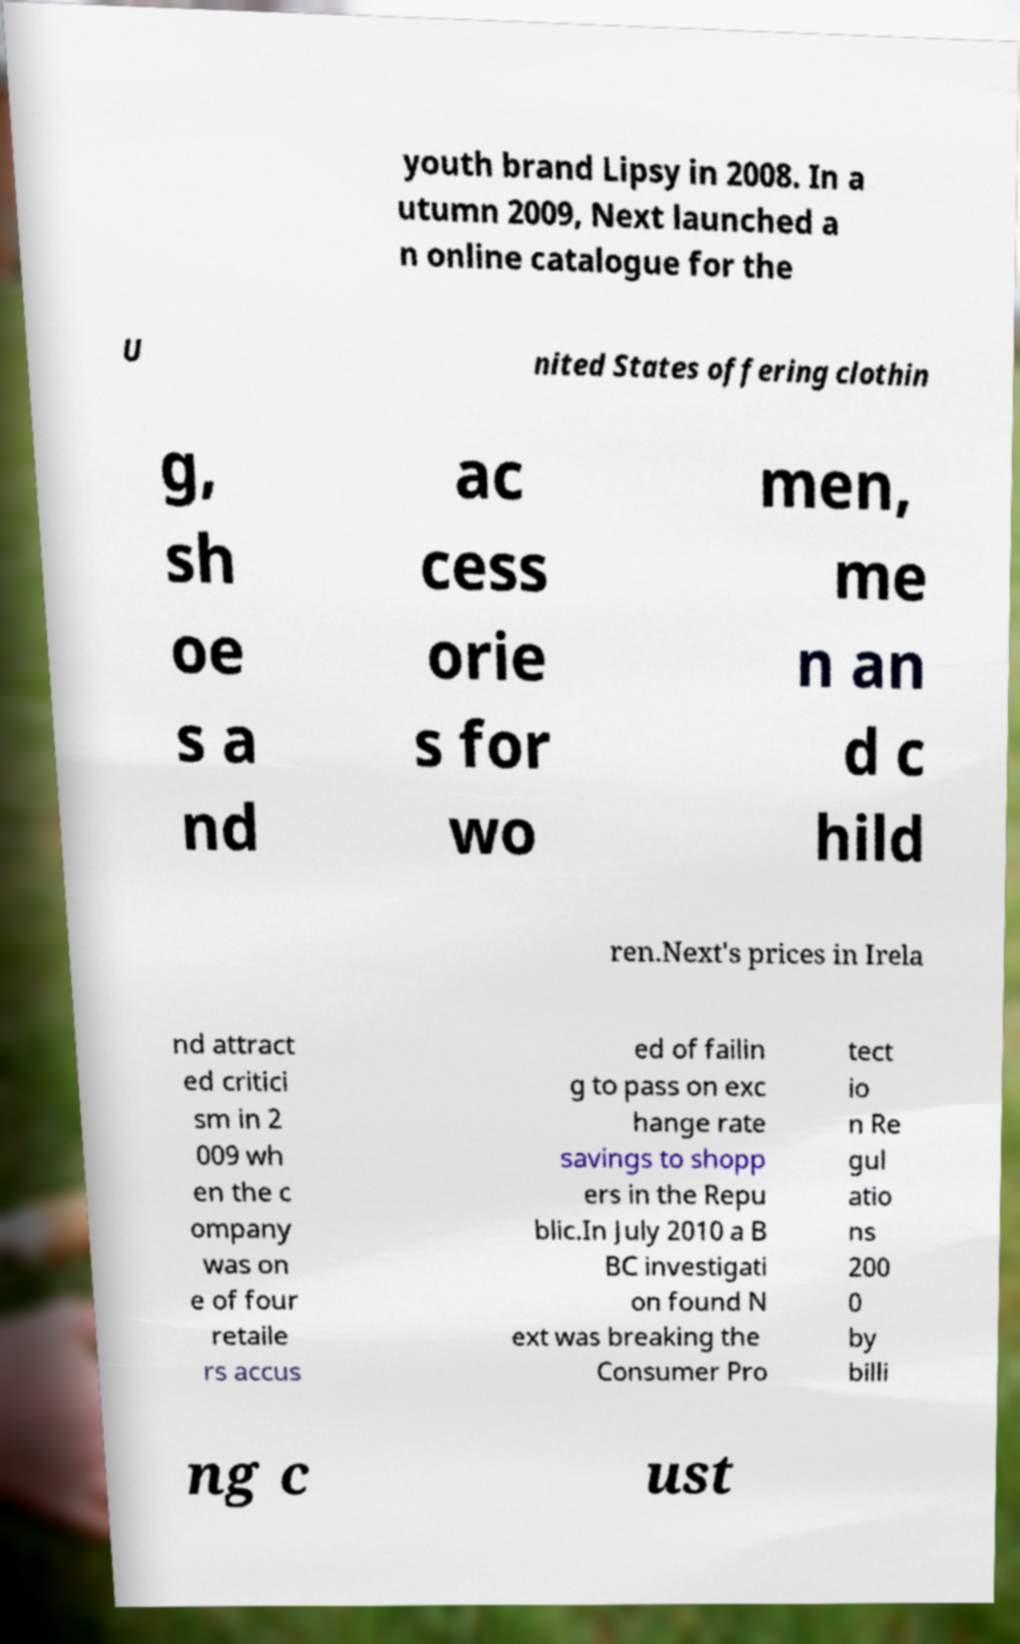Can you accurately transcribe the text from the provided image for me? youth brand Lipsy in 2008. In a utumn 2009, Next launched a n online catalogue for the U nited States offering clothin g, sh oe s a nd ac cess orie s for wo men, me n an d c hild ren.Next's prices in Irela nd attract ed critici sm in 2 009 wh en the c ompany was on e of four retaile rs accus ed of failin g to pass on exc hange rate savings to shopp ers in the Repu blic.In July 2010 a B BC investigati on found N ext was breaking the Consumer Pro tect io n Re gul atio ns 200 0 by billi ng c ust 